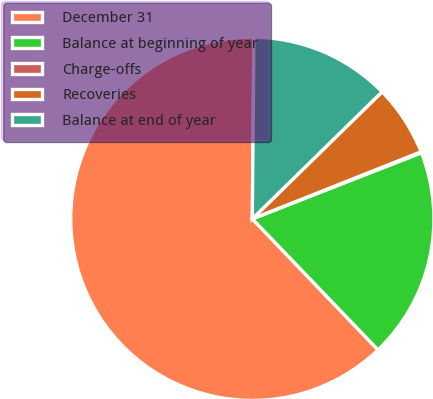Convert chart to OTSL. <chart><loc_0><loc_0><loc_500><loc_500><pie_chart><fcel>December 31<fcel>Balance at beginning of year<fcel>Charge-offs<fcel>Recoveries<fcel>Balance at end of year<nl><fcel>62.3%<fcel>18.76%<fcel>0.09%<fcel>6.31%<fcel>12.53%<nl></chart> 